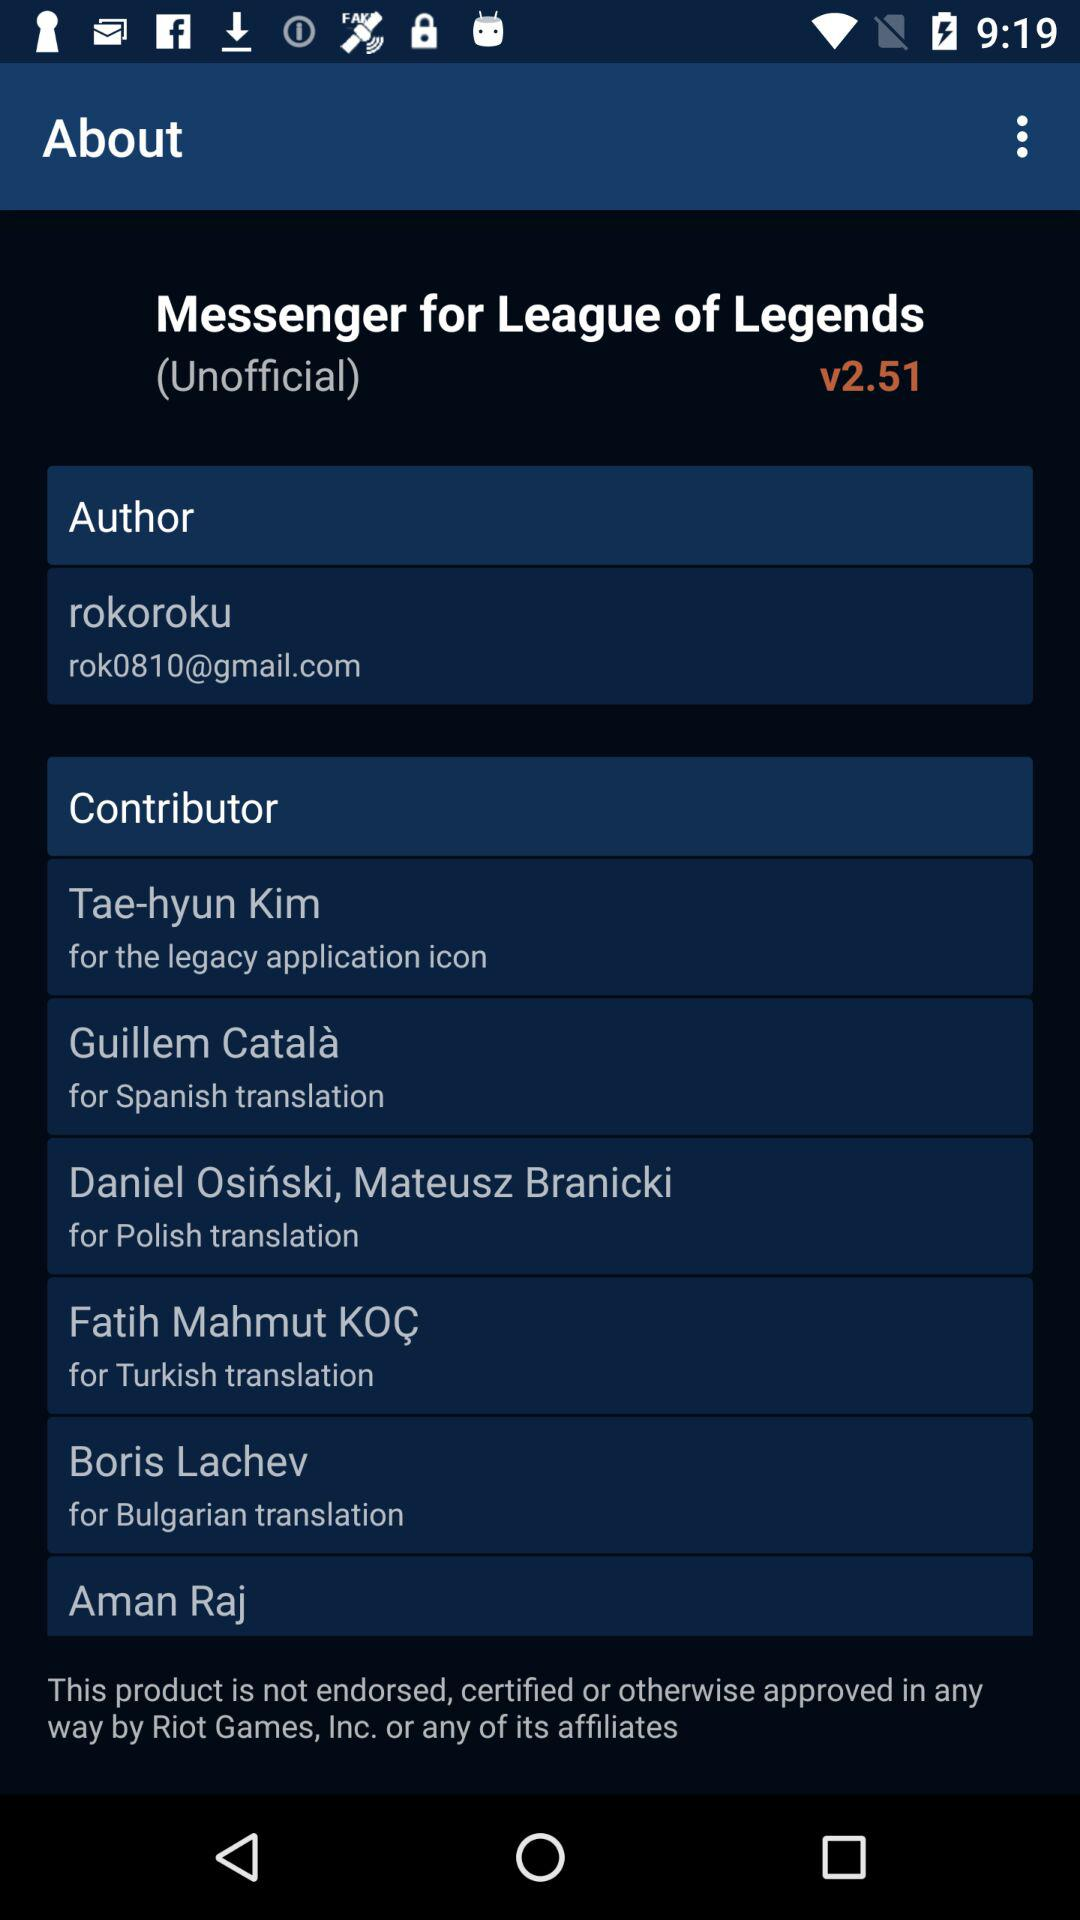What is the version of the application? The version is "v2.51". 